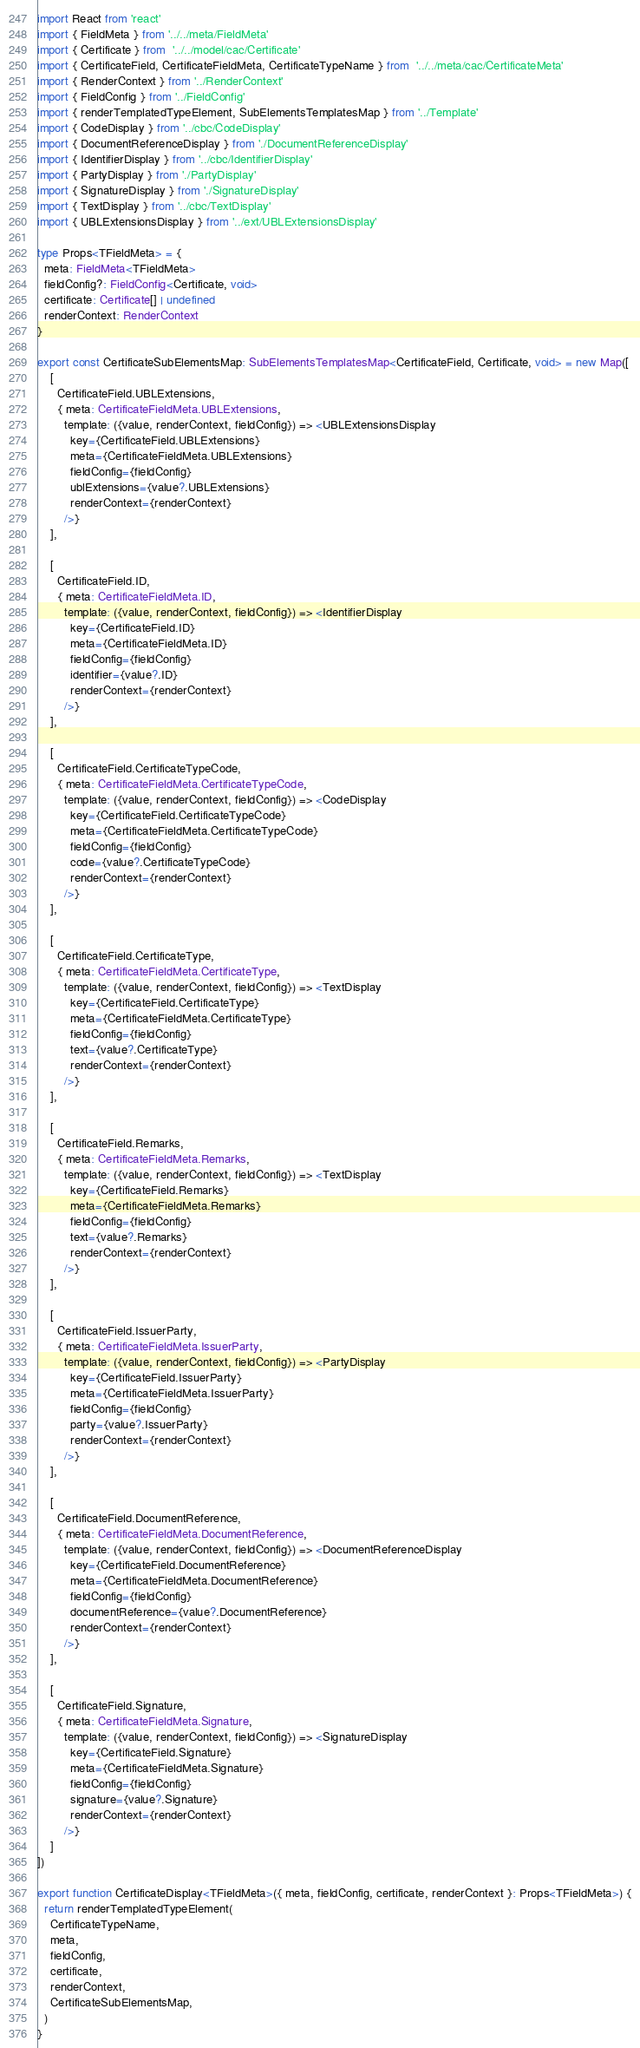<code> <loc_0><loc_0><loc_500><loc_500><_TypeScript_>import React from 'react'
import { FieldMeta } from '../../meta/FieldMeta'
import { Certificate } from  '../../model/cac/Certificate'
import { CertificateField, CertificateFieldMeta, CertificateTypeName } from  '../../meta/cac/CertificateMeta'
import { RenderContext } from '../RenderContext'
import { FieldConfig } from '../FieldConfig'
import { renderTemplatedTypeElement, SubElementsTemplatesMap } from '../Template'
import { CodeDisplay } from '../cbc/CodeDisplay'
import { DocumentReferenceDisplay } from './DocumentReferenceDisplay'
import { IdentifierDisplay } from '../cbc/IdentifierDisplay'
import { PartyDisplay } from './PartyDisplay'
import { SignatureDisplay } from './SignatureDisplay'
import { TextDisplay } from '../cbc/TextDisplay'
import { UBLExtensionsDisplay } from '../ext/UBLExtensionsDisplay'

type Props<TFieldMeta> = {
  meta: FieldMeta<TFieldMeta>
  fieldConfig?: FieldConfig<Certificate, void>
  certificate: Certificate[] | undefined
  renderContext: RenderContext
}

export const CertificateSubElementsMap: SubElementsTemplatesMap<CertificateField, Certificate, void> = new Map([
    [
      CertificateField.UBLExtensions,
      { meta: CertificateFieldMeta.UBLExtensions,
        template: ({value, renderContext, fieldConfig}) => <UBLExtensionsDisplay
          key={CertificateField.UBLExtensions}
          meta={CertificateFieldMeta.UBLExtensions}
          fieldConfig={fieldConfig}
          ublExtensions={value?.UBLExtensions}
          renderContext={renderContext}
        />}
    ],

    [
      CertificateField.ID,
      { meta: CertificateFieldMeta.ID,
        template: ({value, renderContext, fieldConfig}) => <IdentifierDisplay
          key={CertificateField.ID}
          meta={CertificateFieldMeta.ID}
          fieldConfig={fieldConfig}
          identifier={value?.ID}
          renderContext={renderContext}
        />}
    ],

    [
      CertificateField.CertificateTypeCode,
      { meta: CertificateFieldMeta.CertificateTypeCode,
        template: ({value, renderContext, fieldConfig}) => <CodeDisplay
          key={CertificateField.CertificateTypeCode}
          meta={CertificateFieldMeta.CertificateTypeCode}
          fieldConfig={fieldConfig}
          code={value?.CertificateTypeCode}
          renderContext={renderContext}
        />}
    ],

    [
      CertificateField.CertificateType,
      { meta: CertificateFieldMeta.CertificateType,
        template: ({value, renderContext, fieldConfig}) => <TextDisplay
          key={CertificateField.CertificateType}
          meta={CertificateFieldMeta.CertificateType}
          fieldConfig={fieldConfig}
          text={value?.CertificateType}
          renderContext={renderContext}
        />}
    ],

    [
      CertificateField.Remarks,
      { meta: CertificateFieldMeta.Remarks,
        template: ({value, renderContext, fieldConfig}) => <TextDisplay
          key={CertificateField.Remarks}
          meta={CertificateFieldMeta.Remarks}
          fieldConfig={fieldConfig}
          text={value?.Remarks}
          renderContext={renderContext}
        />}
    ],

    [
      CertificateField.IssuerParty,
      { meta: CertificateFieldMeta.IssuerParty,
        template: ({value, renderContext, fieldConfig}) => <PartyDisplay
          key={CertificateField.IssuerParty}
          meta={CertificateFieldMeta.IssuerParty}
          fieldConfig={fieldConfig}
          party={value?.IssuerParty}
          renderContext={renderContext}
        />}
    ],

    [
      CertificateField.DocumentReference,
      { meta: CertificateFieldMeta.DocumentReference,
        template: ({value, renderContext, fieldConfig}) => <DocumentReferenceDisplay
          key={CertificateField.DocumentReference}
          meta={CertificateFieldMeta.DocumentReference}
          fieldConfig={fieldConfig}
          documentReference={value?.DocumentReference}
          renderContext={renderContext}
        />}
    ],

    [
      CertificateField.Signature,
      { meta: CertificateFieldMeta.Signature,
        template: ({value, renderContext, fieldConfig}) => <SignatureDisplay
          key={CertificateField.Signature}
          meta={CertificateFieldMeta.Signature}
          fieldConfig={fieldConfig}
          signature={value?.Signature}
          renderContext={renderContext}
        />}
    ]
]) 

export function CertificateDisplay<TFieldMeta>({ meta, fieldConfig, certificate, renderContext }: Props<TFieldMeta>) {
  return renderTemplatedTypeElement(
    CertificateTypeName,
    meta,
    fieldConfig,
    certificate,
    renderContext,
    CertificateSubElementsMap,
  )
}
</code> 